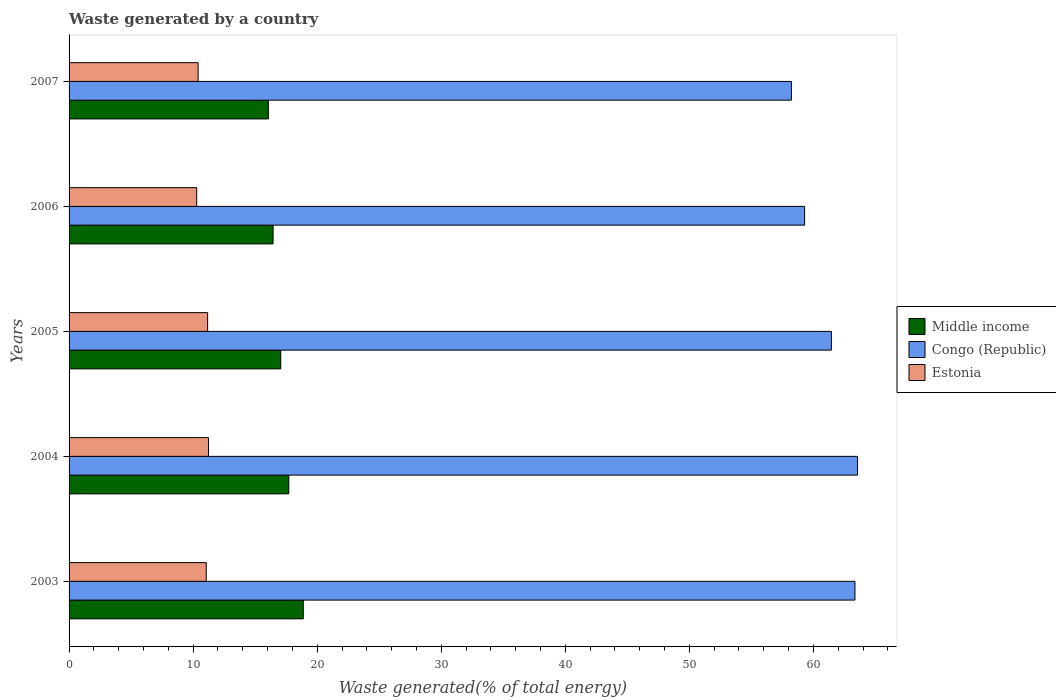How many groups of bars are there?
Ensure brevity in your answer.  5. Are the number of bars per tick equal to the number of legend labels?
Provide a short and direct response. Yes. How many bars are there on the 4th tick from the bottom?
Your answer should be very brief. 3. What is the label of the 4th group of bars from the top?
Your answer should be compact. 2004. What is the total waste generated in Estonia in 2007?
Provide a succinct answer. 10.4. Across all years, what is the maximum total waste generated in Estonia?
Provide a short and direct response. 11.24. Across all years, what is the minimum total waste generated in Congo (Republic)?
Provide a succinct answer. 58.23. In which year was the total waste generated in Estonia maximum?
Provide a short and direct response. 2004. In which year was the total waste generated in Middle income minimum?
Offer a terse response. 2007. What is the total total waste generated in Middle income in the graph?
Your answer should be compact. 86.17. What is the difference between the total waste generated in Middle income in 2005 and that in 2007?
Your response must be concise. 1. What is the difference between the total waste generated in Congo (Republic) in 2004 and the total waste generated in Middle income in 2003?
Make the answer very short. 44.68. What is the average total waste generated in Estonia per year?
Make the answer very short. 10.83. In the year 2007, what is the difference between the total waste generated in Estonia and total waste generated in Middle income?
Keep it short and to the point. -5.66. In how many years, is the total waste generated in Middle income greater than 28 %?
Your answer should be compact. 0. What is the ratio of the total waste generated in Middle income in 2006 to that in 2007?
Provide a short and direct response. 1.02. Is the difference between the total waste generated in Estonia in 2004 and 2006 greater than the difference between the total waste generated in Middle income in 2004 and 2006?
Ensure brevity in your answer.  No. What is the difference between the highest and the second highest total waste generated in Estonia?
Offer a very short reply. 0.07. What is the difference between the highest and the lowest total waste generated in Congo (Republic)?
Offer a very short reply. 5.33. Is the sum of the total waste generated in Congo (Republic) in 2003 and 2006 greater than the maximum total waste generated in Middle income across all years?
Your answer should be very brief. Yes. What does the 2nd bar from the top in 2006 represents?
Offer a terse response. Congo (Republic). How many bars are there?
Give a very brief answer. 15. Are all the bars in the graph horizontal?
Offer a very short reply. Yes. How many years are there in the graph?
Ensure brevity in your answer.  5. Does the graph contain any zero values?
Keep it short and to the point. No. Does the graph contain grids?
Make the answer very short. No. How many legend labels are there?
Your answer should be compact. 3. What is the title of the graph?
Make the answer very short. Waste generated by a country. What is the label or title of the X-axis?
Your answer should be very brief. Waste generated(% of total energy). What is the Waste generated(% of total energy) of Middle income in 2003?
Offer a very short reply. 18.88. What is the Waste generated(% of total energy) of Congo (Republic) in 2003?
Your answer should be compact. 63.35. What is the Waste generated(% of total energy) in Estonia in 2003?
Make the answer very short. 11.06. What is the Waste generated(% of total energy) in Middle income in 2004?
Offer a terse response. 17.71. What is the Waste generated(% of total energy) of Congo (Republic) in 2004?
Ensure brevity in your answer.  63.56. What is the Waste generated(% of total energy) of Estonia in 2004?
Ensure brevity in your answer.  11.24. What is the Waste generated(% of total energy) in Middle income in 2005?
Your answer should be compact. 17.06. What is the Waste generated(% of total energy) of Congo (Republic) in 2005?
Ensure brevity in your answer.  61.45. What is the Waste generated(% of total energy) of Estonia in 2005?
Provide a short and direct response. 11.17. What is the Waste generated(% of total energy) of Middle income in 2006?
Keep it short and to the point. 16.44. What is the Waste generated(% of total energy) of Congo (Republic) in 2006?
Provide a short and direct response. 59.29. What is the Waste generated(% of total energy) of Estonia in 2006?
Your response must be concise. 10.29. What is the Waste generated(% of total energy) of Middle income in 2007?
Give a very brief answer. 16.06. What is the Waste generated(% of total energy) of Congo (Republic) in 2007?
Ensure brevity in your answer.  58.23. What is the Waste generated(% of total energy) of Estonia in 2007?
Make the answer very short. 10.4. Across all years, what is the maximum Waste generated(% of total energy) in Middle income?
Offer a terse response. 18.88. Across all years, what is the maximum Waste generated(% of total energy) in Congo (Republic)?
Your answer should be compact. 63.56. Across all years, what is the maximum Waste generated(% of total energy) of Estonia?
Make the answer very short. 11.24. Across all years, what is the minimum Waste generated(% of total energy) in Middle income?
Your answer should be compact. 16.06. Across all years, what is the minimum Waste generated(% of total energy) of Congo (Republic)?
Make the answer very short. 58.23. Across all years, what is the minimum Waste generated(% of total energy) in Estonia?
Offer a terse response. 10.29. What is the total Waste generated(% of total energy) of Middle income in the graph?
Provide a short and direct response. 86.17. What is the total Waste generated(% of total energy) of Congo (Republic) in the graph?
Keep it short and to the point. 305.88. What is the total Waste generated(% of total energy) of Estonia in the graph?
Make the answer very short. 54.15. What is the difference between the Waste generated(% of total energy) in Middle income in 2003 and that in 2004?
Your response must be concise. 1.17. What is the difference between the Waste generated(% of total energy) of Congo (Republic) in 2003 and that in 2004?
Offer a very short reply. -0.21. What is the difference between the Waste generated(% of total energy) in Estonia in 2003 and that in 2004?
Make the answer very short. -0.18. What is the difference between the Waste generated(% of total energy) of Middle income in 2003 and that in 2005?
Your answer should be very brief. 1.82. What is the difference between the Waste generated(% of total energy) of Congo (Republic) in 2003 and that in 2005?
Give a very brief answer. 1.9. What is the difference between the Waste generated(% of total energy) of Estonia in 2003 and that in 2005?
Your answer should be compact. -0.11. What is the difference between the Waste generated(% of total energy) of Middle income in 2003 and that in 2006?
Keep it short and to the point. 2.44. What is the difference between the Waste generated(% of total energy) of Congo (Republic) in 2003 and that in 2006?
Ensure brevity in your answer.  4.06. What is the difference between the Waste generated(% of total energy) in Estonia in 2003 and that in 2006?
Make the answer very short. 0.77. What is the difference between the Waste generated(% of total energy) of Middle income in 2003 and that in 2007?
Your answer should be compact. 2.82. What is the difference between the Waste generated(% of total energy) in Congo (Republic) in 2003 and that in 2007?
Your answer should be compact. 5.12. What is the difference between the Waste generated(% of total energy) in Estonia in 2003 and that in 2007?
Your answer should be very brief. 0.65. What is the difference between the Waste generated(% of total energy) of Middle income in 2004 and that in 2005?
Offer a very short reply. 0.65. What is the difference between the Waste generated(% of total energy) of Congo (Republic) in 2004 and that in 2005?
Provide a succinct answer. 2.11. What is the difference between the Waste generated(% of total energy) of Estonia in 2004 and that in 2005?
Your response must be concise. 0.07. What is the difference between the Waste generated(% of total energy) in Middle income in 2004 and that in 2006?
Keep it short and to the point. 1.27. What is the difference between the Waste generated(% of total energy) in Congo (Republic) in 2004 and that in 2006?
Provide a succinct answer. 4.27. What is the difference between the Waste generated(% of total energy) of Estonia in 2004 and that in 2006?
Your response must be concise. 0.95. What is the difference between the Waste generated(% of total energy) of Middle income in 2004 and that in 2007?
Provide a short and direct response. 1.65. What is the difference between the Waste generated(% of total energy) of Congo (Republic) in 2004 and that in 2007?
Make the answer very short. 5.33. What is the difference between the Waste generated(% of total energy) of Estonia in 2004 and that in 2007?
Keep it short and to the point. 0.83. What is the difference between the Waste generated(% of total energy) of Middle income in 2005 and that in 2006?
Your answer should be compact. 0.62. What is the difference between the Waste generated(% of total energy) in Congo (Republic) in 2005 and that in 2006?
Offer a terse response. 2.16. What is the difference between the Waste generated(% of total energy) in Estonia in 2005 and that in 2006?
Give a very brief answer. 0.88. What is the difference between the Waste generated(% of total energy) in Congo (Republic) in 2005 and that in 2007?
Your answer should be very brief. 3.22. What is the difference between the Waste generated(% of total energy) of Estonia in 2005 and that in 2007?
Give a very brief answer. 0.76. What is the difference between the Waste generated(% of total energy) in Middle income in 2006 and that in 2007?
Give a very brief answer. 0.38. What is the difference between the Waste generated(% of total energy) in Congo (Republic) in 2006 and that in 2007?
Your response must be concise. 1.06. What is the difference between the Waste generated(% of total energy) of Estonia in 2006 and that in 2007?
Provide a succinct answer. -0.12. What is the difference between the Waste generated(% of total energy) of Middle income in 2003 and the Waste generated(% of total energy) of Congo (Republic) in 2004?
Make the answer very short. -44.68. What is the difference between the Waste generated(% of total energy) in Middle income in 2003 and the Waste generated(% of total energy) in Estonia in 2004?
Your answer should be compact. 7.64. What is the difference between the Waste generated(% of total energy) of Congo (Republic) in 2003 and the Waste generated(% of total energy) of Estonia in 2004?
Your response must be concise. 52.11. What is the difference between the Waste generated(% of total energy) of Middle income in 2003 and the Waste generated(% of total energy) of Congo (Republic) in 2005?
Ensure brevity in your answer.  -42.57. What is the difference between the Waste generated(% of total energy) of Middle income in 2003 and the Waste generated(% of total energy) of Estonia in 2005?
Provide a short and direct response. 7.71. What is the difference between the Waste generated(% of total energy) of Congo (Republic) in 2003 and the Waste generated(% of total energy) of Estonia in 2005?
Give a very brief answer. 52.18. What is the difference between the Waste generated(% of total energy) in Middle income in 2003 and the Waste generated(% of total energy) in Congo (Republic) in 2006?
Your answer should be compact. -40.41. What is the difference between the Waste generated(% of total energy) in Middle income in 2003 and the Waste generated(% of total energy) in Estonia in 2006?
Make the answer very short. 8.59. What is the difference between the Waste generated(% of total energy) of Congo (Republic) in 2003 and the Waste generated(% of total energy) of Estonia in 2006?
Your response must be concise. 53.06. What is the difference between the Waste generated(% of total energy) in Middle income in 2003 and the Waste generated(% of total energy) in Congo (Republic) in 2007?
Offer a terse response. -39.35. What is the difference between the Waste generated(% of total energy) in Middle income in 2003 and the Waste generated(% of total energy) in Estonia in 2007?
Ensure brevity in your answer.  8.48. What is the difference between the Waste generated(% of total energy) in Congo (Republic) in 2003 and the Waste generated(% of total energy) in Estonia in 2007?
Offer a very short reply. 52.95. What is the difference between the Waste generated(% of total energy) in Middle income in 2004 and the Waste generated(% of total energy) in Congo (Republic) in 2005?
Give a very brief answer. -43.74. What is the difference between the Waste generated(% of total energy) of Middle income in 2004 and the Waste generated(% of total energy) of Estonia in 2005?
Your answer should be compact. 6.54. What is the difference between the Waste generated(% of total energy) of Congo (Republic) in 2004 and the Waste generated(% of total energy) of Estonia in 2005?
Your answer should be very brief. 52.39. What is the difference between the Waste generated(% of total energy) in Middle income in 2004 and the Waste generated(% of total energy) in Congo (Republic) in 2006?
Keep it short and to the point. -41.58. What is the difference between the Waste generated(% of total energy) of Middle income in 2004 and the Waste generated(% of total energy) of Estonia in 2006?
Your response must be concise. 7.43. What is the difference between the Waste generated(% of total energy) in Congo (Republic) in 2004 and the Waste generated(% of total energy) in Estonia in 2006?
Your answer should be very brief. 53.27. What is the difference between the Waste generated(% of total energy) of Middle income in 2004 and the Waste generated(% of total energy) of Congo (Republic) in 2007?
Provide a short and direct response. -40.51. What is the difference between the Waste generated(% of total energy) in Middle income in 2004 and the Waste generated(% of total energy) in Estonia in 2007?
Offer a terse response. 7.31. What is the difference between the Waste generated(% of total energy) in Congo (Republic) in 2004 and the Waste generated(% of total energy) in Estonia in 2007?
Provide a short and direct response. 53.16. What is the difference between the Waste generated(% of total energy) of Middle income in 2005 and the Waste generated(% of total energy) of Congo (Republic) in 2006?
Offer a terse response. -42.23. What is the difference between the Waste generated(% of total energy) in Middle income in 2005 and the Waste generated(% of total energy) in Estonia in 2006?
Keep it short and to the point. 6.78. What is the difference between the Waste generated(% of total energy) in Congo (Republic) in 2005 and the Waste generated(% of total energy) in Estonia in 2006?
Your answer should be compact. 51.16. What is the difference between the Waste generated(% of total energy) in Middle income in 2005 and the Waste generated(% of total energy) in Congo (Republic) in 2007?
Provide a short and direct response. -41.16. What is the difference between the Waste generated(% of total energy) in Middle income in 2005 and the Waste generated(% of total energy) in Estonia in 2007?
Offer a very short reply. 6.66. What is the difference between the Waste generated(% of total energy) of Congo (Republic) in 2005 and the Waste generated(% of total energy) of Estonia in 2007?
Your answer should be very brief. 51.05. What is the difference between the Waste generated(% of total energy) of Middle income in 2006 and the Waste generated(% of total energy) of Congo (Republic) in 2007?
Make the answer very short. -41.78. What is the difference between the Waste generated(% of total energy) of Middle income in 2006 and the Waste generated(% of total energy) of Estonia in 2007?
Make the answer very short. 6.04. What is the difference between the Waste generated(% of total energy) in Congo (Republic) in 2006 and the Waste generated(% of total energy) in Estonia in 2007?
Your response must be concise. 48.89. What is the average Waste generated(% of total energy) of Middle income per year?
Offer a very short reply. 17.23. What is the average Waste generated(% of total energy) in Congo (Republic) per year?
Ensure brevity in your answer.  61.17. What is the average Waste generated(% of total energy) of Estonia per year?
Give a very brief answer. 10.83. In the year 2003, what is the difference between the Waste generated(% of total energy) of Middle income and Waste generated(% of total energy) of Congo (Republic)?
Your response must be concise. -44.47. In the year 2003, what is the difference between the Waste generated(% of total energy) of Middle income and Waste generated(% of total energy) of Estonia?
Make the answer very short. 7.82. In the year 2003, what is the difference between the Waste generated(% of total energy) in Congo (Republic) and Waste generated(% of total energy) in Estonia?
Offer a terse response. 52.29. In the year 2004, what is the difference between the Waste generated(% of total energy) of Middle income and Waste generated(% of total energy) of Congo (Republic)?
Offer a terse response. -45.85. In the year 2004, what is the difference between the Waste generated(% of total energy) in Middle income and Waste generated(% of total energy) in Estonia?
Keep it short and to the point. 6.47. In the year 2004, what is the difference between the Waste generated(% of total energy) of Congo (Republic) and Waste generated(% of total energy) of Estonia?
Offer a terse response. 52.32. In the year 2005, what is the difference between the Waste generated(% of total energy) of Middle income and Waste generated(% of total energy) of Congo (Republic)?
Give a very brief answer. -44.39. In the year 2005, what is the difference between the Waste generated(% of total energy) of Middle income and Waste generated(% of total energy) of Estonia?
Keep it short and to the point. 5.9. In the year 2005, what is the difference between the Waste generated(% of total energy) of Congo (Republic) and Waste generated(% of total energy) of Estonia?
Provide a short and direct response. 50.28. In the year 2006, what is the difference between the Waste generated(% of total energy) of Middle income and Waste generated(% of total energy) of Congo (Republic)?
Offer a terse response. -42.85. In the year 2006, what is the difference between the Waste generated(% of total energy) in Middle income and Waste generated(% of total energy) in Estonia?
Offer a very short reply. 6.16. In the year 2006, what is the difference between the Waste generated(% of total energy) of Congo (Republic) and Waste generated(% of total energy) of Estonia?
Provide a short and direct response. 49. In the year 2007, what is the difference between the Waste generated(% of total energy) in Middle income and Waste generated(% of total energy) in Congo (Republic)?
Give a very brief answer. -42.16. In the year 2007, what is the difference between the Waste generated(% of total energy) of Middle income and Waste generated(% of total energy) of Estonia?
Make the answer very short. 5.66. In the year 2007, what is the difference between the Waste generated(% of total energy) in Congo (Republic) and Waste generated(% of total energy) in Estonia?
Your answer should be very brief. 47.82. What is the ratio of the Waste generated(% of total energy) of Middle income in 2003 to that in 2004?
Make the answer very short. 1.07. What is the ratio of the Waste generated(% of total energy) in Estonia in 2003 to that in 2004?
Offer a very short reply. 0.98. What is the ratio of the Waste generated(% of total energy) of Middle income in 2003 to that in 2005?
Provide a succinct answer. 1.11. What is the ratio of the Waste generated(% of total energy) in Congo (Republic) in 2003 to that in 2005?
Offer a very short reply. 1.03. What is the ratio of the Waste generated(% of total energy) in Estonia in 2003 to that in 2005?
Keep it short and to the point. 0.99. What is the ratio of the Waste generated(% of total energy) in Middle income in 2003 to that in 2006?
Provide a succinct answer. 1.15. What is the ratio of the Waste generated(% of total energy) in Congo (Republic) in 2003 to that in 2006?
Your response must be concise. 1.07. What is the ratio of the Waste generated(% of total energy) of Estonia in 2003 to that in 2006?
Offer a terse response. 1.07. What is the ratio of the Waste generated(% of total energy) in Middle income in 2003 to that in 2007?
Give a very brief answer. 1.18. What is the ratio of the Waste generated(% of total energy) in Congo (Republic) in 2003 to that in 2007?
Your response must be concise. 1.09. What is the ratio of the Waste generated(% of total energy) in Estonia in 2003 to that in 2007?
Your response must be concise. 1.06. What is the ratio of the Waste generated(% of total energy) of Middle income in 2004 to that in 2005?
Offer a very short reply. 1.04. What is the ratio of the Waste generated(% of total energy) of Congo (Republic) in 2004 to that in 2005?
Make the answer very short. 1.03. What is the ratio of the Waste generated(% of total energy) in Estonia in 2004 to that in 2005?
Give a very brief answer. 1.01. What is the ratio of the Waste generated(% of total energy) in Middle income in 2004 to that in 2006?
Offer a very short reply. 1.08. What is the ratio of the Waste generated(% of total energy) in Congo (Republic) in 2004 to that in 2006?
Offer a terse response. 1.07. What is the ratio of the Waste generated(% of total energy) of Estonia in 2004 to that in 2006?
Provide a succinct answer. 1.09. What is the ratio of the Waste generated(% of total energy) of Middle income in 2004 to that in 2007?
Provide a succinct answer. 1.1. What is the ratio of the Waste generated(% of total energy) of Congo (Republic) in 2004 to that in 2007?
Ensure brevity in your answer.  1.09. What is the ratio of the Waste generated(% of total energy) in Estonia in 2004 to that in 2007?
Ensure brevity in your answer.  1.08. What is the ratio of the Waste generated(% of total energy) in Middle income in 2005 to that in 2006?
Keep it short and to the point. 1.04. What is the ratio of the Waste generated(% of total energy) of Congo (Republic) in 2005 to that in 2006?
Your response must be concise. 1.04. What is the ratio of the Waste generated(% of total energy) in Estonia in 2005 to that in 2006?
Make the answer very short. 1.09. What is the ratio of the Waste generated(% of total energy) of Middle income in 2005 to that in 2007?
Your answer should be very brief. 1.06. What is the ratio of the Waste generated(% of total energy) in Congo (Republic) in 2005 to that in 2007?
Keep it short and to the point. 1.06. What is the ratio of the Waste generated(% of total energy) in Estonia in 2005 to that in 2007?
Your answer should be compact. 1.07. What is the ratio of the Waste generated(% of total energy) in Middle income in 2006 to that in 2007?
Your answer should be very brief. 1.02. What is the ratio of the Waste generated(% of total energy) of Congo (Republic) in 2006 to that in 2007?
Ensure brevity in your answer.  1.02. What is the difference between the highest and the second highest Waste generated(% of total energy) in Middle income?
Offer a very short reply. 1.17. What is the difference between the highest and the second highest Waste generated(% of total energy) in Congo (Republic)?
Your answer should be compact. 0.21. What is the difference between the highest and the second highest Waste generated(% of total energy) in Estonia?
Your response must be concise. 0.07. What is the difference between the highest and the lowest Waste generated(% of total energy) in Middle income?
Give a very brief answer. 2.82. What is the difference between the highest and the lowest Waste generated(% of total energy) in Congo (Republic)?
Your response must be concise. 5.33. What is the difference between the highest and the lowest Waste generated(% of total energy) in Estonia?
Provide a succinct answer. 0.95. 